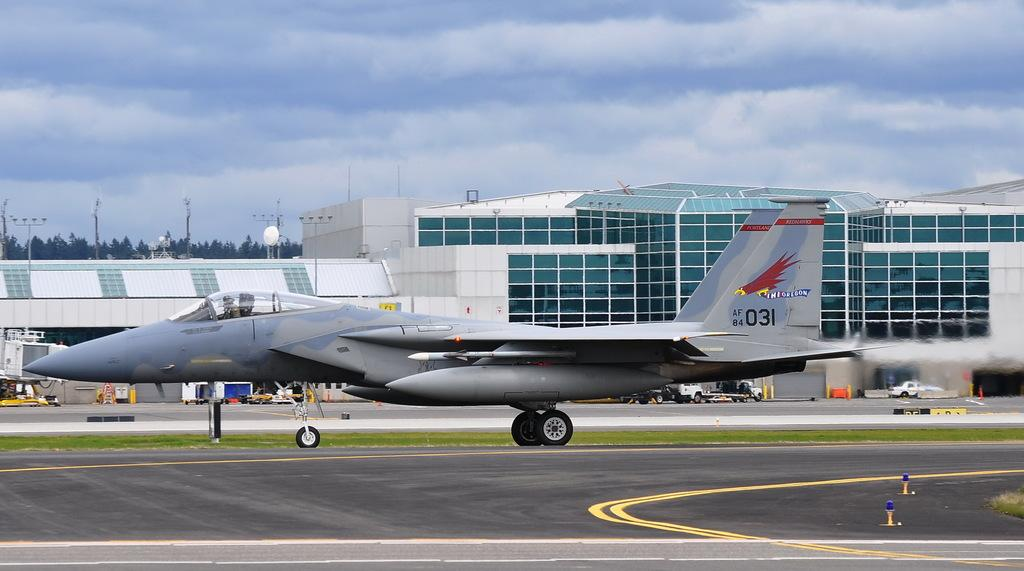<image>
Summarize the visual content of the image. A fighter jet for the state of Oregon landing on an airstrip. 